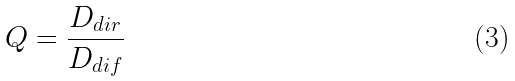<formula> <loc_0><loc_0><loc_500><loc_500>Q = \frac { D _ { d i r } } { D _ { d i f } }</formula> 